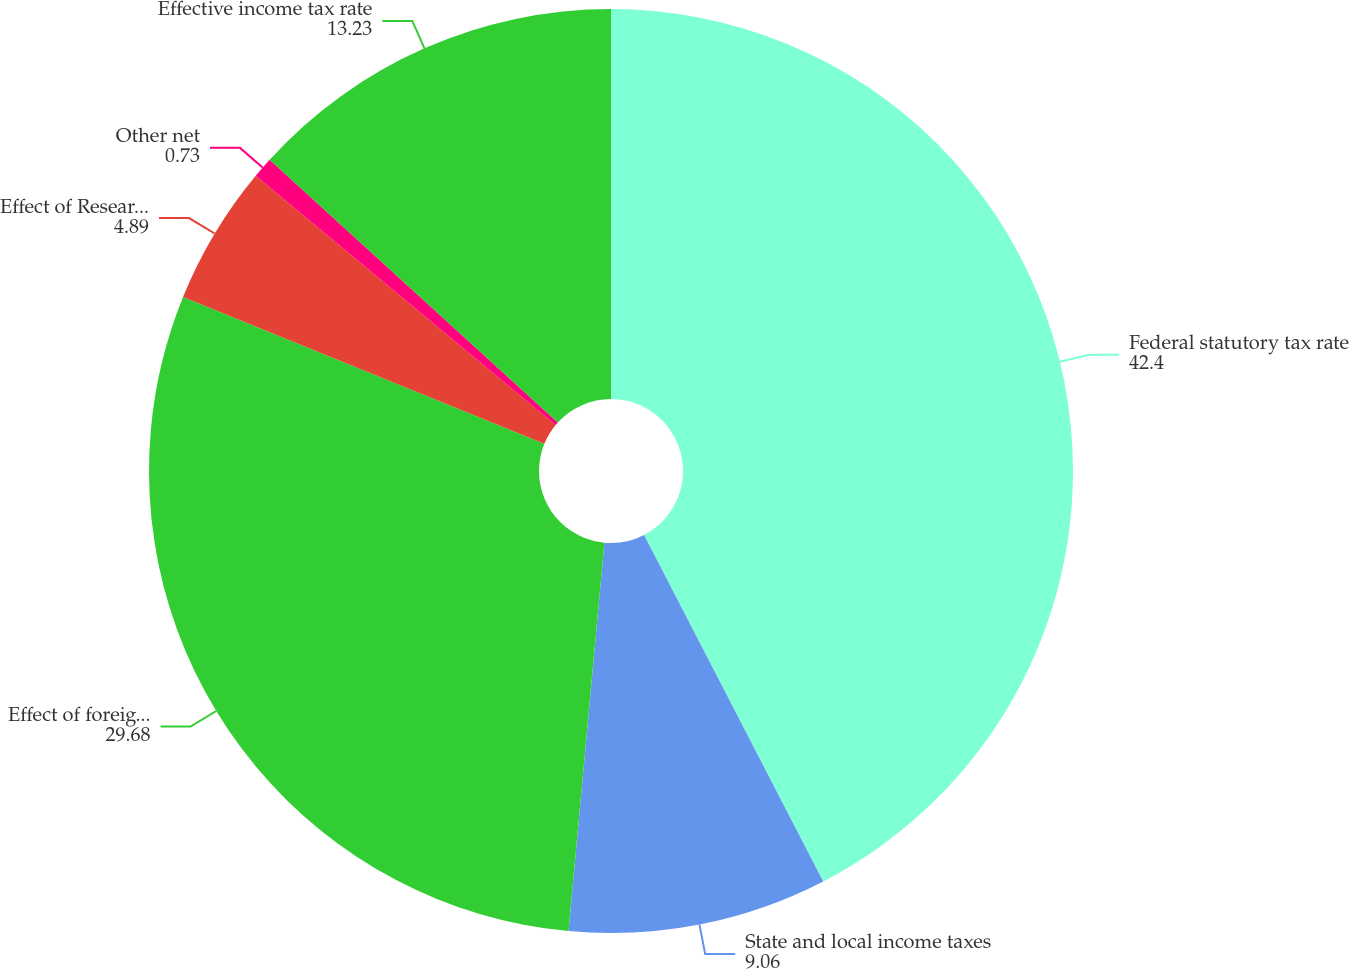Convert chart. <chart><loc_0><loc_0><loc_500><loc_500><pie_chart><fcel>Federal statutory tax rate<fcel>State and local income taxes<fcel>Effect of foreign and Puerto<fcel>Effect of Research Credits and<fcel>Other net<fcel>Effective income tax rate<nl><fcel>42.4%<fcel>9.06%<fcel>29.68%<fcel>4.89%<fcel>0.73%<fcel>13.23%<nl></chart> 